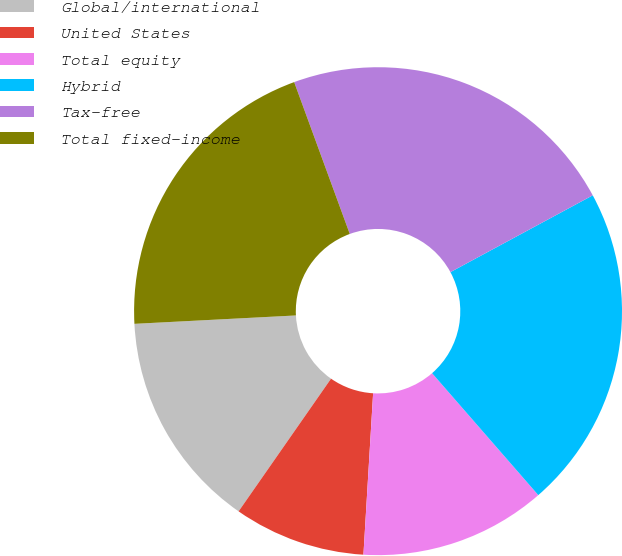<chart> <loc_0><loc_0><loc_500><loc_500><pie_chart><fcel>Global/international<fcel>United States<fcel>Total equity<fcel>Hybrid<fcel>Tax-free<fcel>Total fixed-income<nl><fcel>14.49%<fcel>8.73%<fcel>12.36%<fcel>21.47%<fcel>22.71%<fcel>20.24%<nl></chart> 